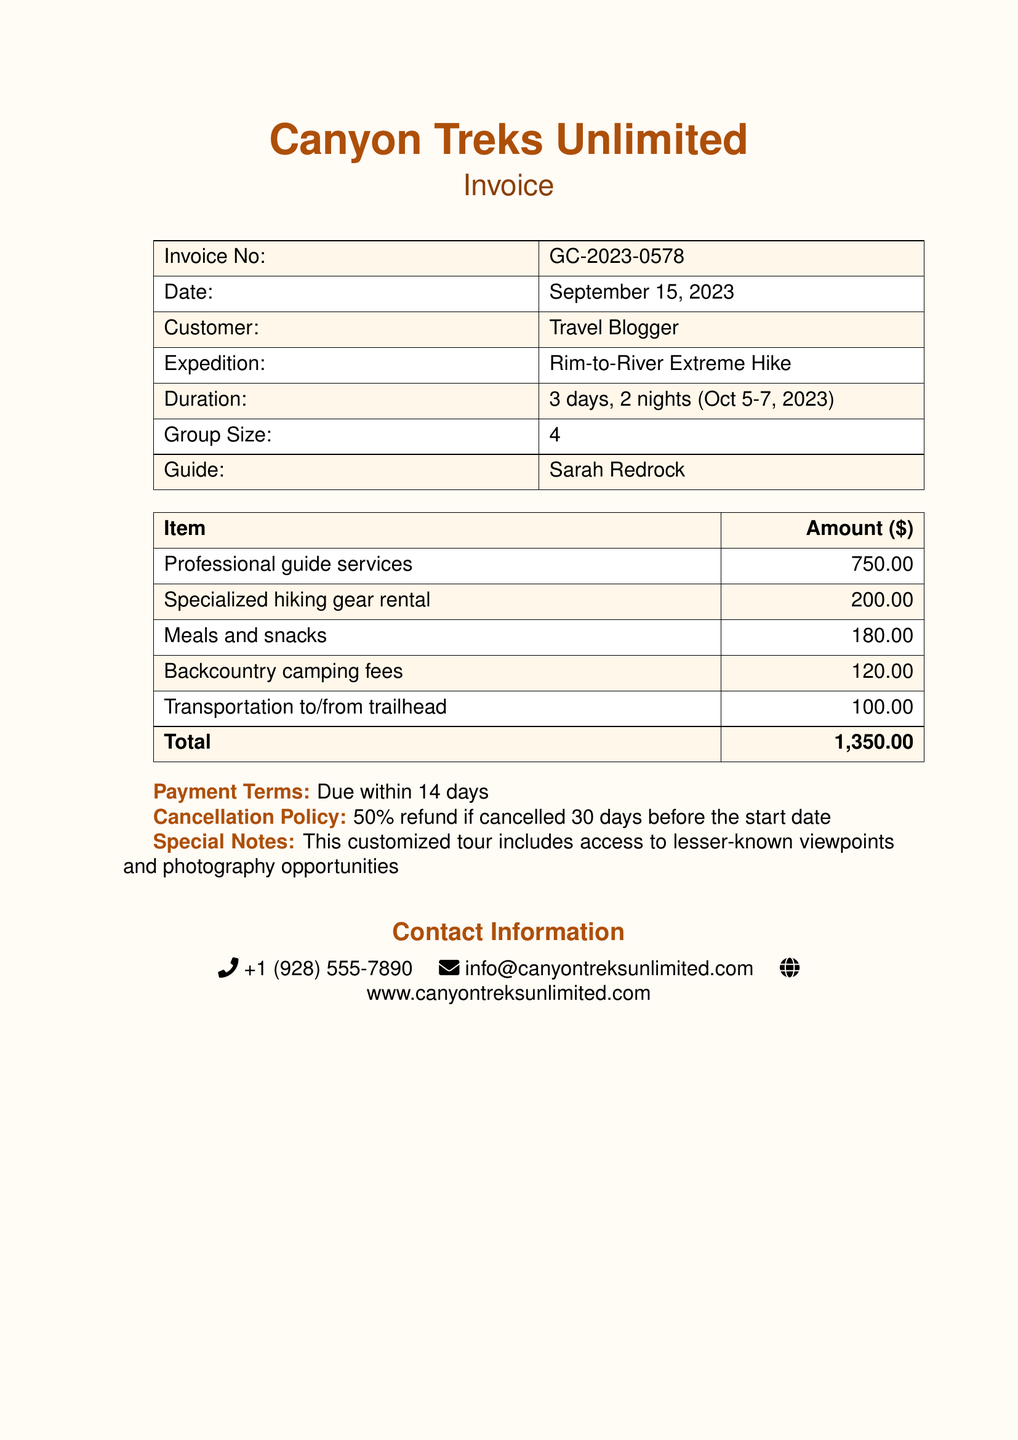What is the invoice number? The invoice number is stated clearly in the document as a reference for the transaction.
Answer: GC-2023-0578 Who is the guide for the expedition? The guide's name is provided in the document, indicating who will lead the hiking trip.
Answer: Sarah Redrock What is the total amount due? The document lists the total amount at the end of the billing section, summarizing all costs.
Answer: 1,350.00 What are the payment terms? The payment terms are detailed in the document, specifying when the payment is expected.
Answer: Due within 14 days What is the duration of the expedition? The duration is mentioned, indicating how long the hiking expedition will last.
Answer: 3 days, 2 nights What is the cancellation policy? The cancellation policy explains the terms regarding refunds if the expedition is canceled.
Answer: 50% refund if cancelled 30 days before the start date How many people are in the group? The group size is listed, providing information on the number of participants for the hike.
Answer: 4 What type of hiking gear is included? The types of services provided in the document specify the gear included for the hike.
Answer: Specialized hiking gear rental What dates does the expedition take place? The dates are clearly mentioned in the document, indicating when the event is scheduled.
Answer: Oct 5-7, 2023 